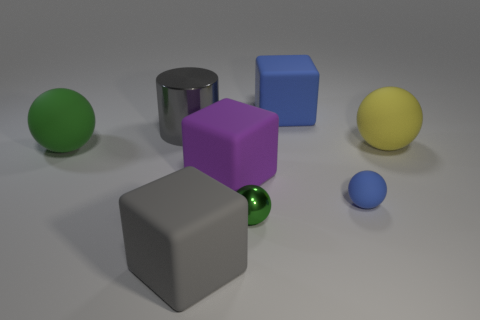Subtract 1 balls. How many balls are left? 3 Add 1 big brown blocks. How many objects exist? 9 Subtract all blocks. How many objects are left? 5 Subtract all large matte objects. Subtract all tiny green metal things. How many objects are left? 2 Add 1 yellow spheres. How many yellow spheres are left? 2 Add 1 large green things. How many large green things exist? 2 Subtract 0 blue cylinders. How many objects are left? 8 